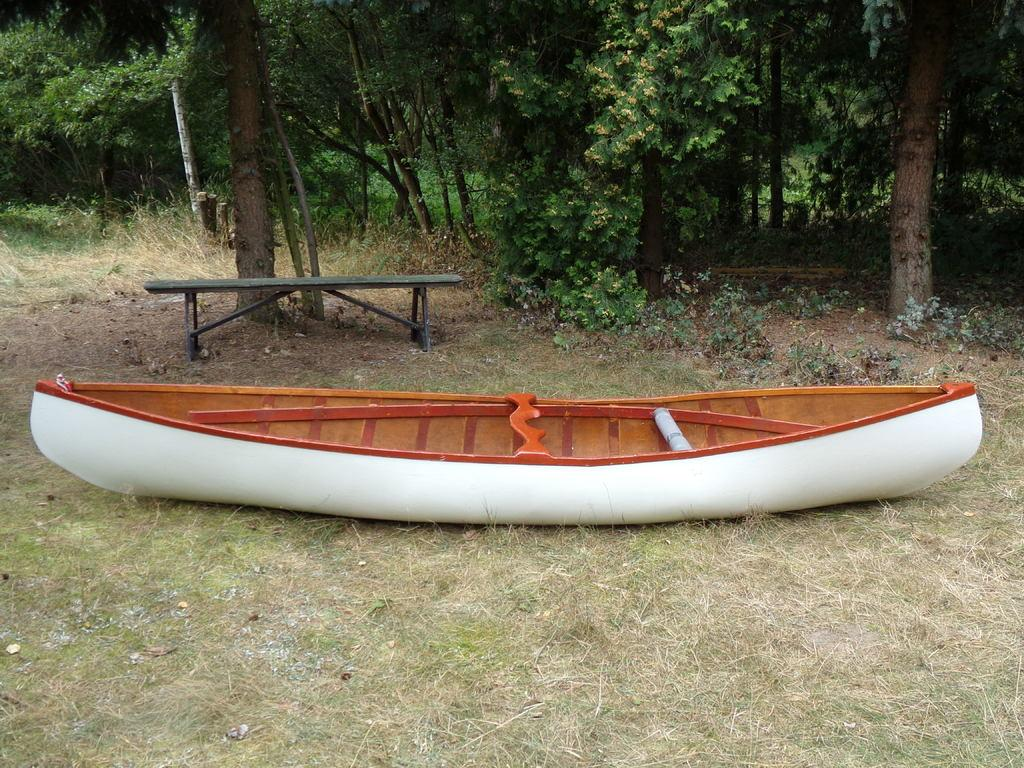What is the main subject in the center of the image? There is a white color boat in the center of the image. What is the surface on which the boat is placed? The boat is on a grass surface. What can be seen in the background of the image? There are trees in the background of the image. Can you identify any other objects in the image? Yes, there is a bench in the image. What type of scent can be detected from the boat in the image? There is no indication of a scent in the image, as it only shows a white color boat on a grass surface with trees in the background and a bench nearby. 